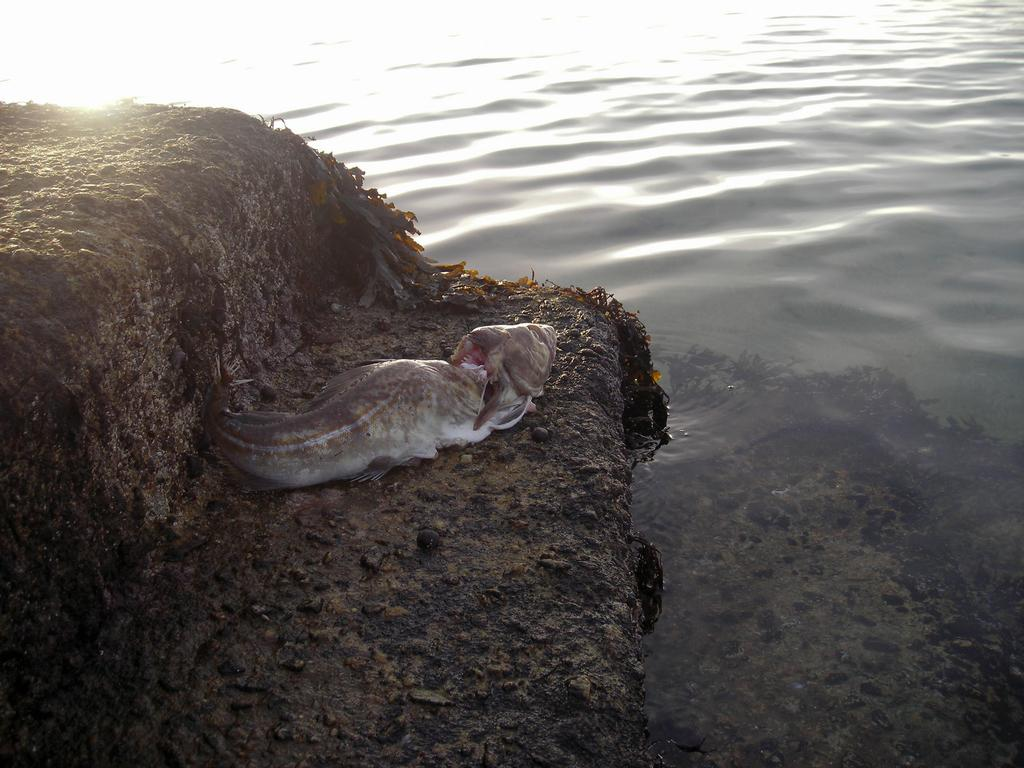What is the main subject of the image? There is a fish out of the water in the image. What other objects can be seen in the image? There is a stone in the image. What is the surrounding environment like? There is water visible in the image. How many girls are playing with the deer in the image? There are no girls or deer present in the image; it features a fish out of the water and a stone. 